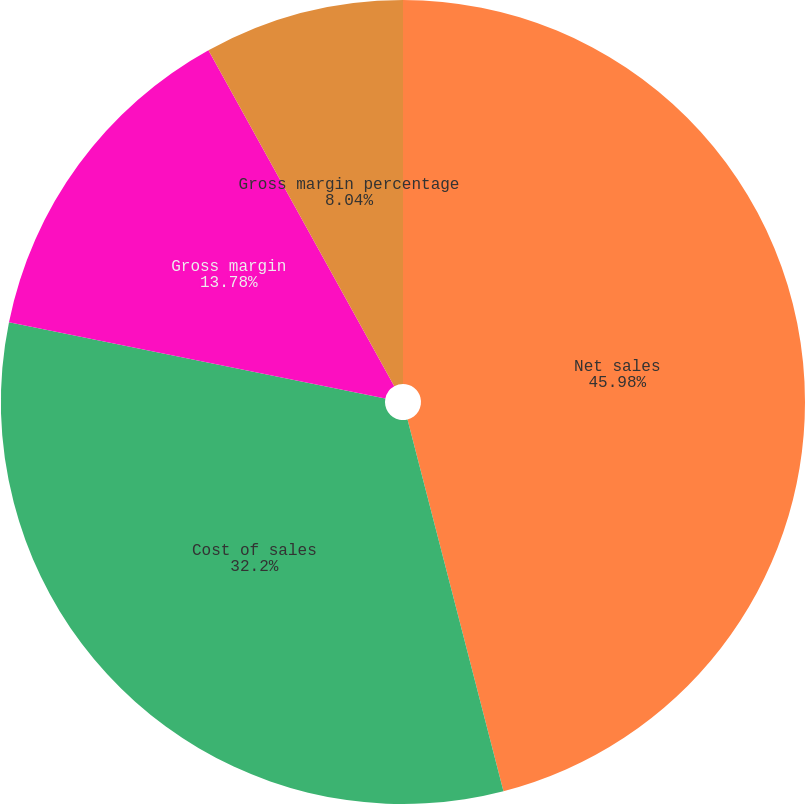Convert chart to OTSL. <chart><loc_0><loc_0><loc_500><loc_500><pie_chart><fcel>Net sales<fcel>Cost of sales<fcel>Gross margin<fcel>Gross margin percentage<nl><fcel>45.98%<fcel>32.2%<fcel>13.78%<fcel>8.04%<nl></chart> 